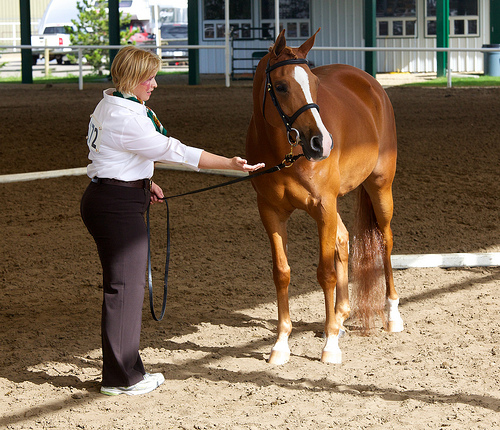<image>
Is the lady on the horse? No. The lady is not positioned on the horse. They may be near each other, but the lady is not supported by or resting on top of the horse. 